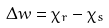<formula> <loc_0><loc_0><loc_500><loc_500>\Delta w = \chi _ { r } - \chi _ { s }</formula> 